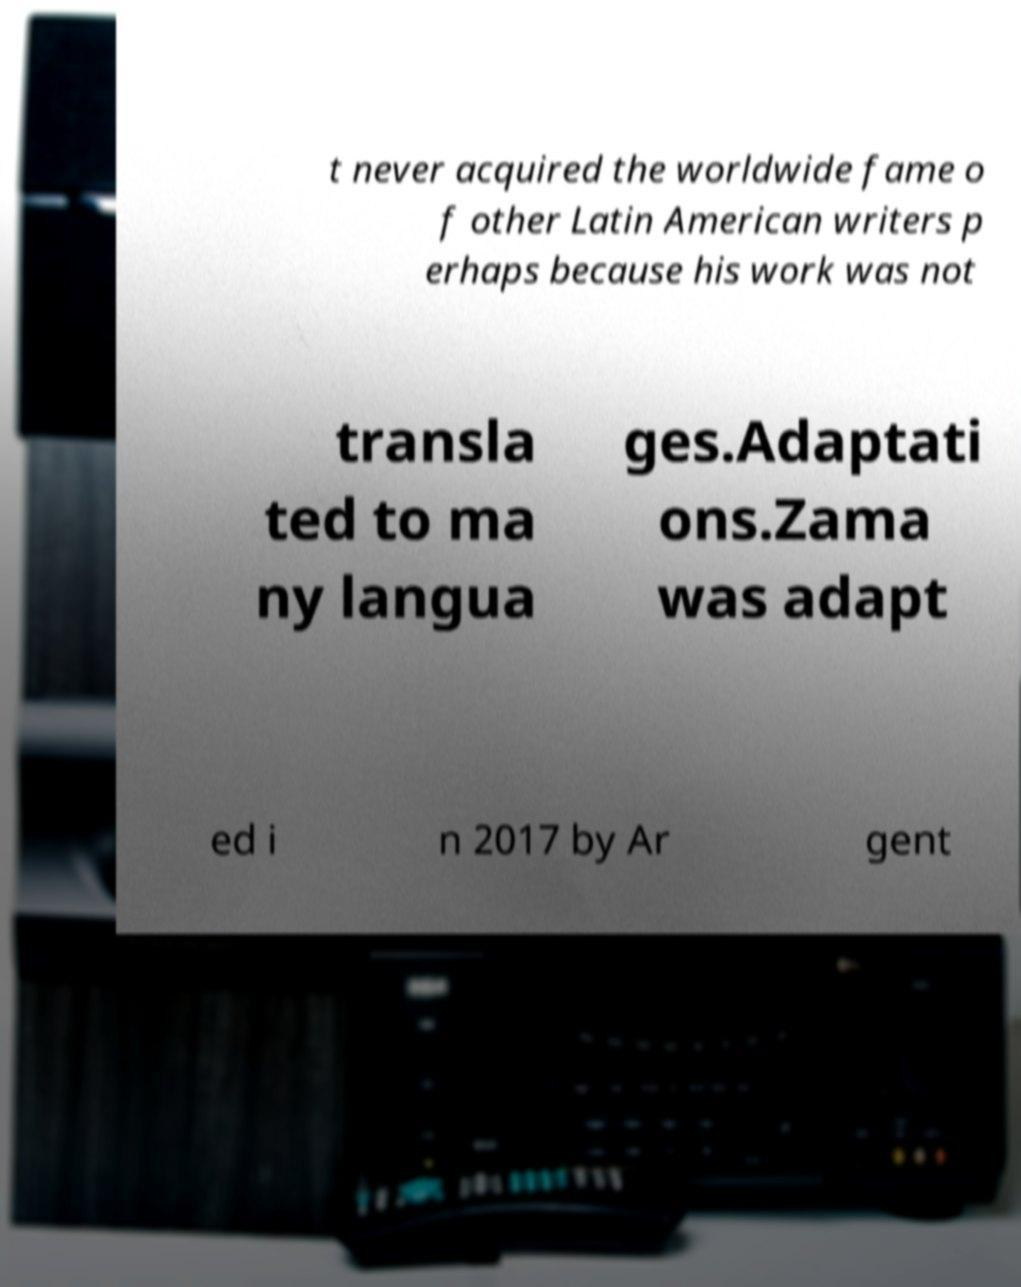Could you assist in decoding the text presented in this image and type it out clearly? t never acquired the worldwide fame o f other Latin American writers p erhaps because his work was not transla ted to ma ny langua ges.Adaptati ons.Zama was adapt ed i n 2017 by Ar gent 